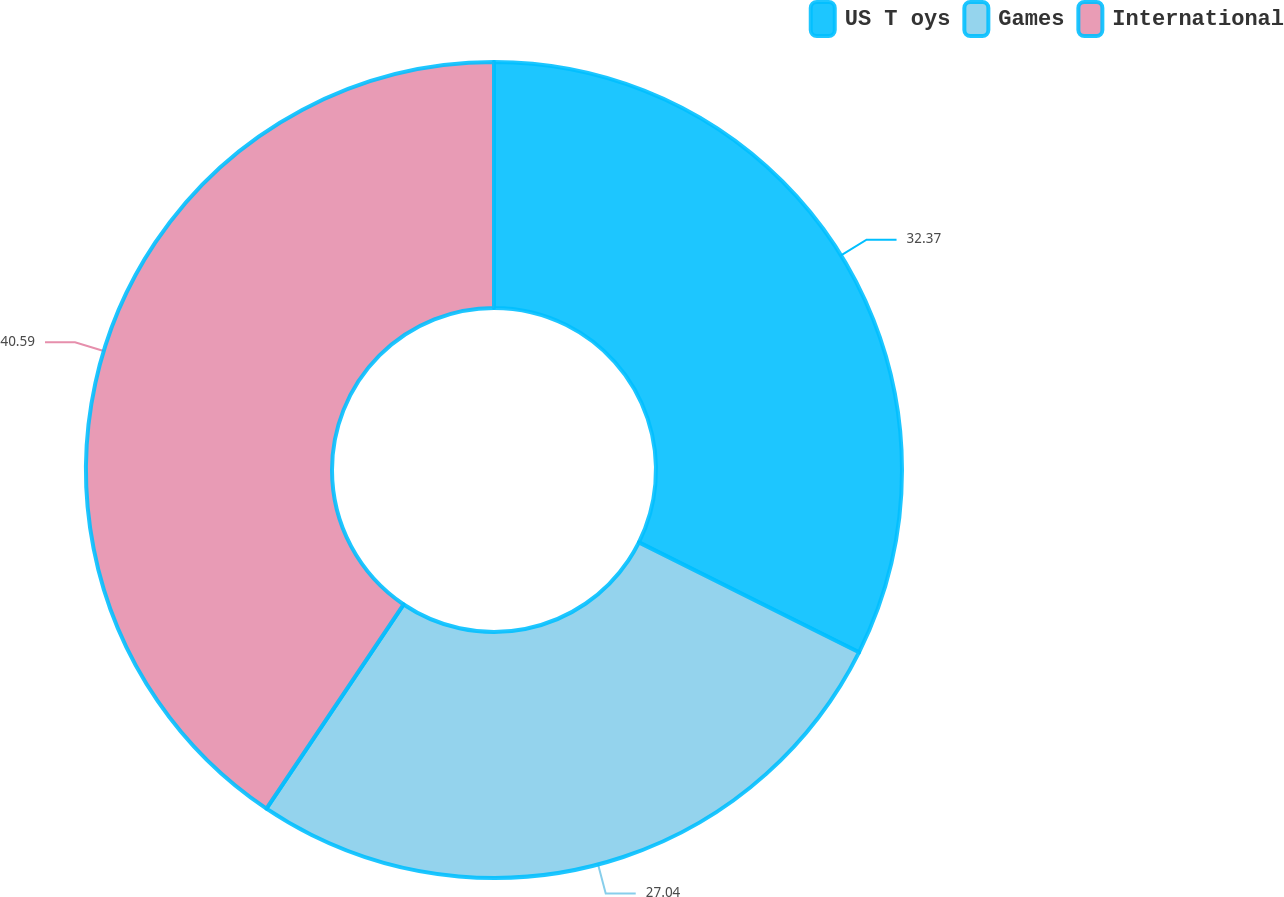Convert chart to OTSL. <chart><loc_0><loc_0><loc_500><loc_500><pie_chart><fcel>US T oys<fcel>Games<fcel>International<nl><fcel>32.37%<fcel>27.04%<fcel>40.58%<nl></chart> 